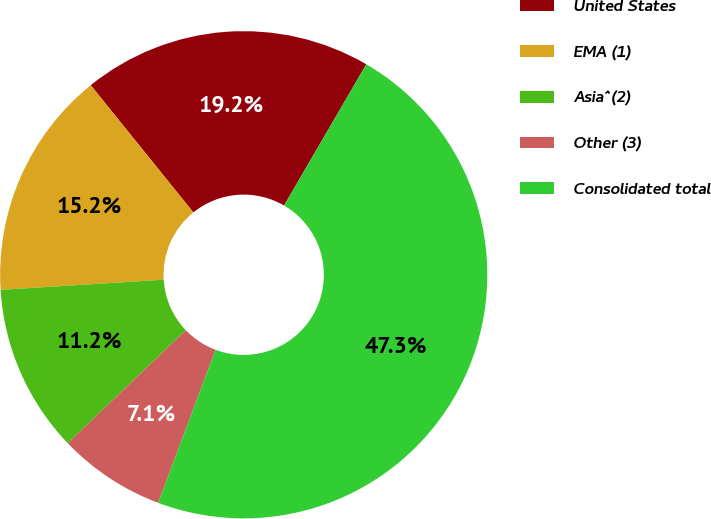<chart> <loc_0><loc_0><loc_500><loc_500><pie_chart><fcel>United States<fcel>EMA (1)<fcel>Asia^(2)<fcel>Other (3)<fcel>Consolidated total<nl><fcel>19.2%<fcel>15.18%<fcel>11.16%<fcel>7.14%<fcel>47.32%<nl></chart> 